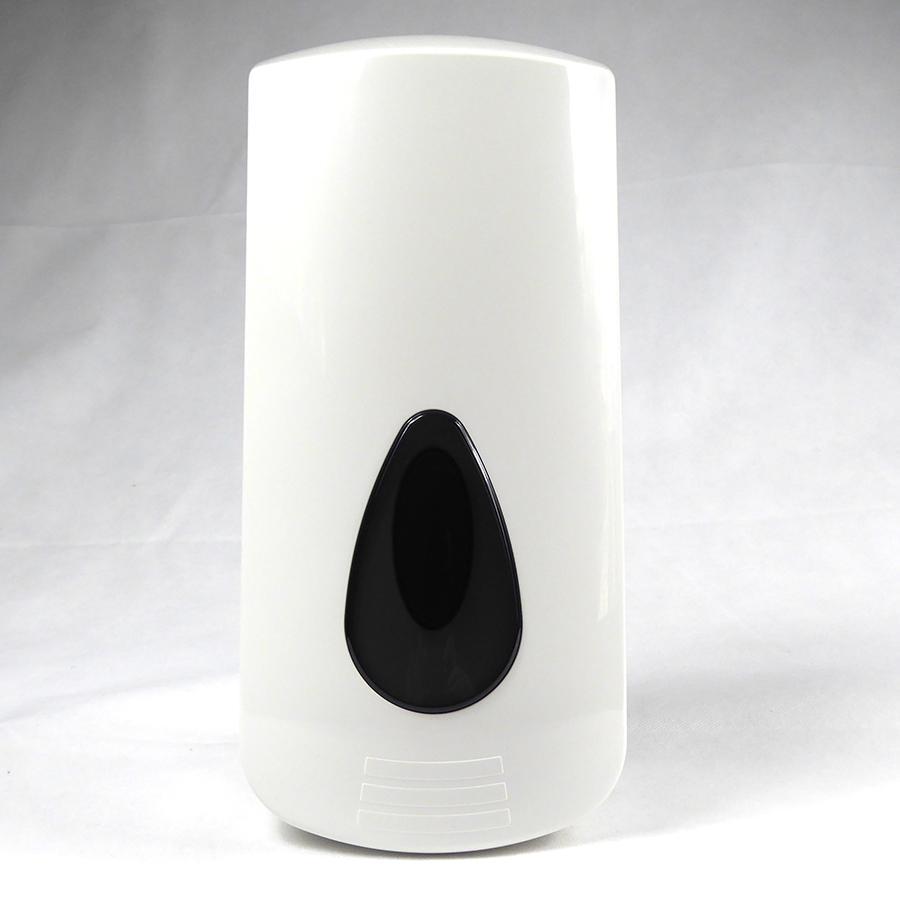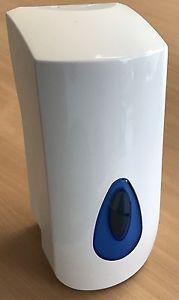The first image is the image on the left, the second image is the image on the right. Examine the images to the left and right. Is the description "One image shows a dispenser sitting on a wood-grain surface." accurate? Answer yes or no. Yes. The first image is the image on the left, the second image is the image on the right. Given the left and right images, does the statement "The dispenser in the image on the right is sitting on wood." hold true? Answer yes or no. Yes. 